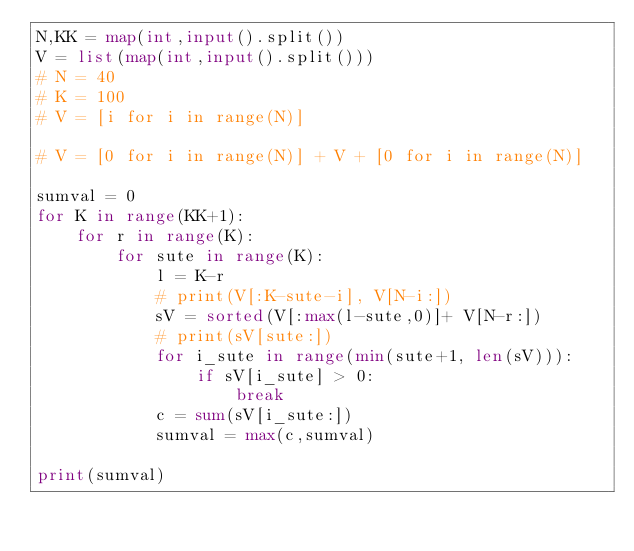Convert code to text. <code><loc_0><loc_0><loc_500><loc_500><_Python_>N,KK = map(int,input().split())
V = list(map(int,input().split()))
# N = 40
# K = 100
# V = [i for i in range(N)]

# V = [0 for i in range(N)] + V + [0 for i in range(N)] 

sumval = 0
for K in range(KK+1):
    for r in range(K):
        for sute in range(K):
            l = K-r
            # print(V[:K-sute-i], V[N-i:])
            sV = sorted(V[:max(l-sute,0)]+ V[N-r:])
            # print(sV[sute:])
            for i_sute in range(min(sute+1, len(sV))):
                if sV[i_sute] > 0:
                    break
            c = sum(sV[i_sute:])
            sumval = max(c,sumval)

print(sumval)</code> 